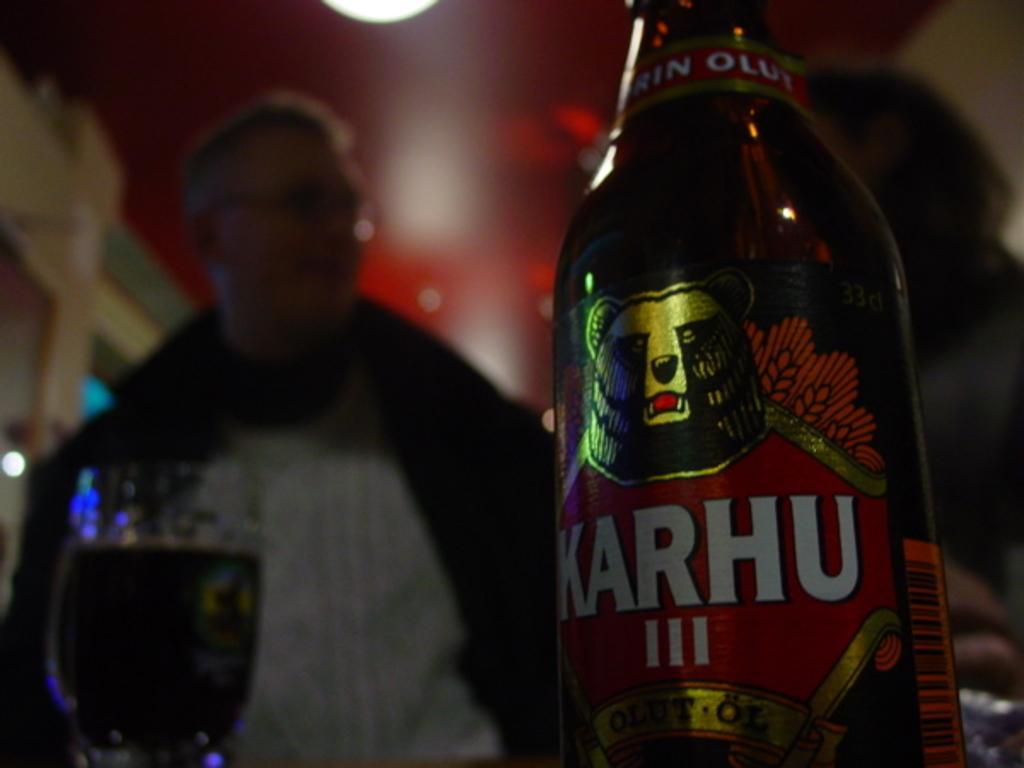In one or two sentences, can you explain what this image depicts? This is an image clicked in the dark. On the right side, I can see a bottle. On the left side there is a wine glass. In the background, I can see two persons. On the top of the image I can see the lights. 